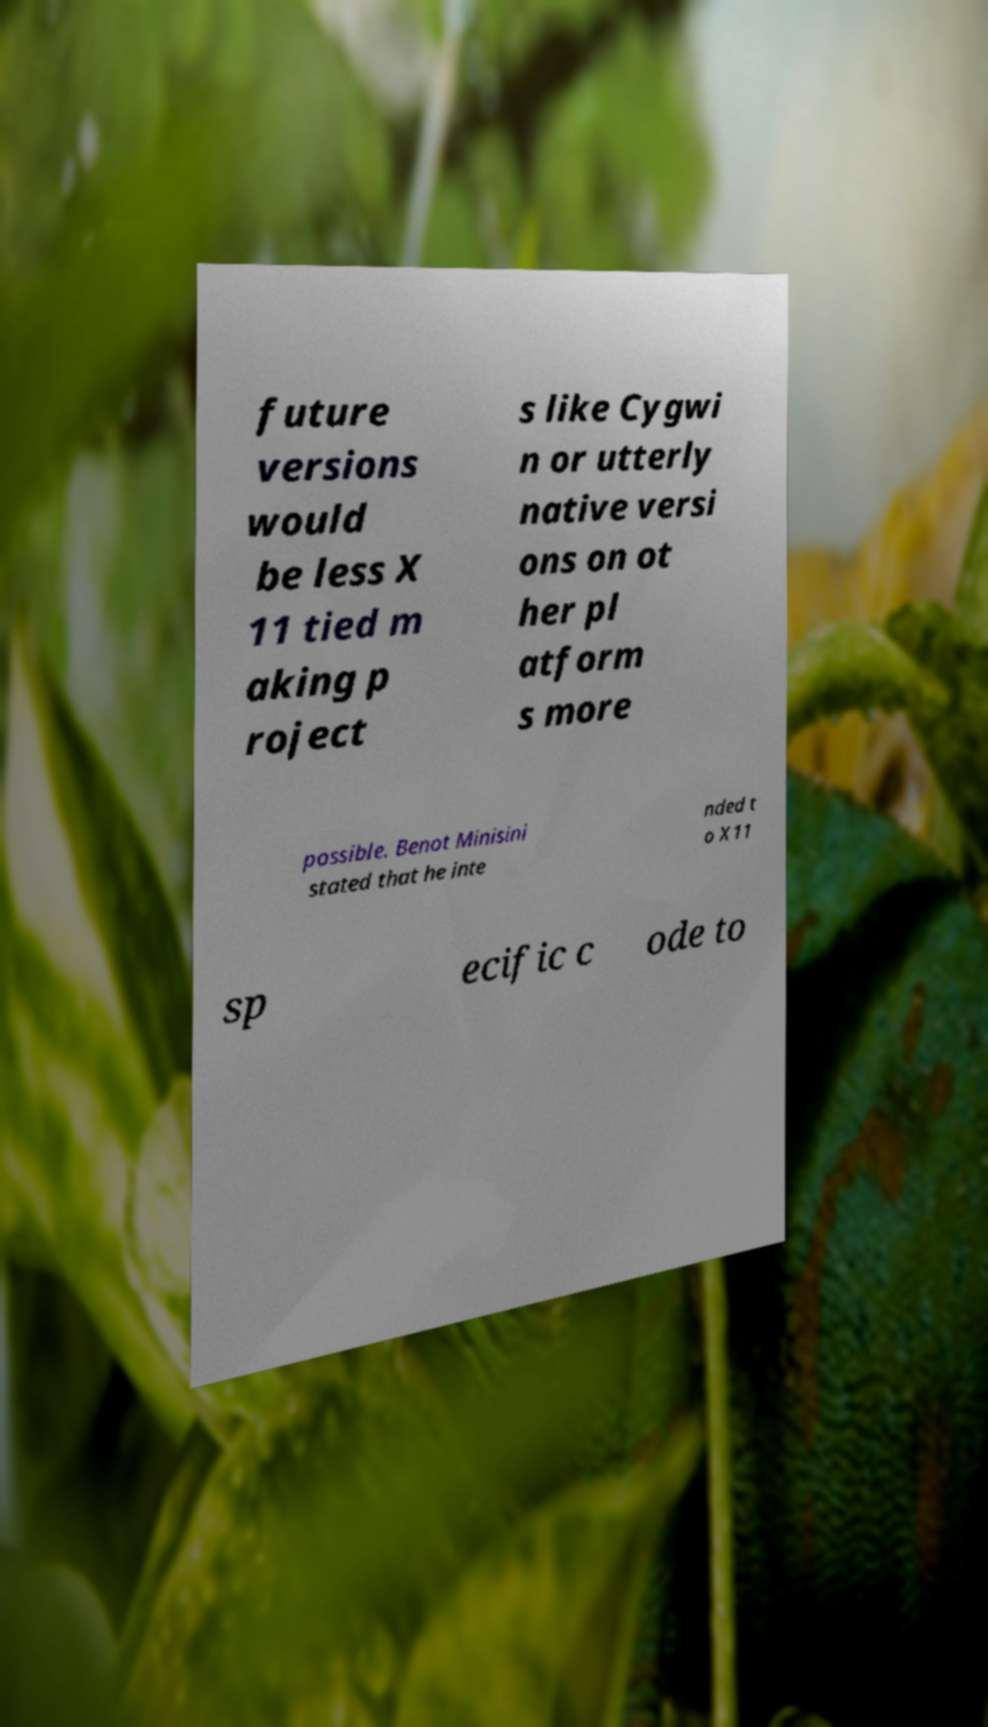Could you assist in decoding the text presented in this image and type it out clearly? future versions would be less X 11 tied m aking p roject s like Cygwi n or utterly native versi ons on ot her pl atform s more possible. Benot Minisini stated that he inte nded t o X11 sp ecific c ode to 